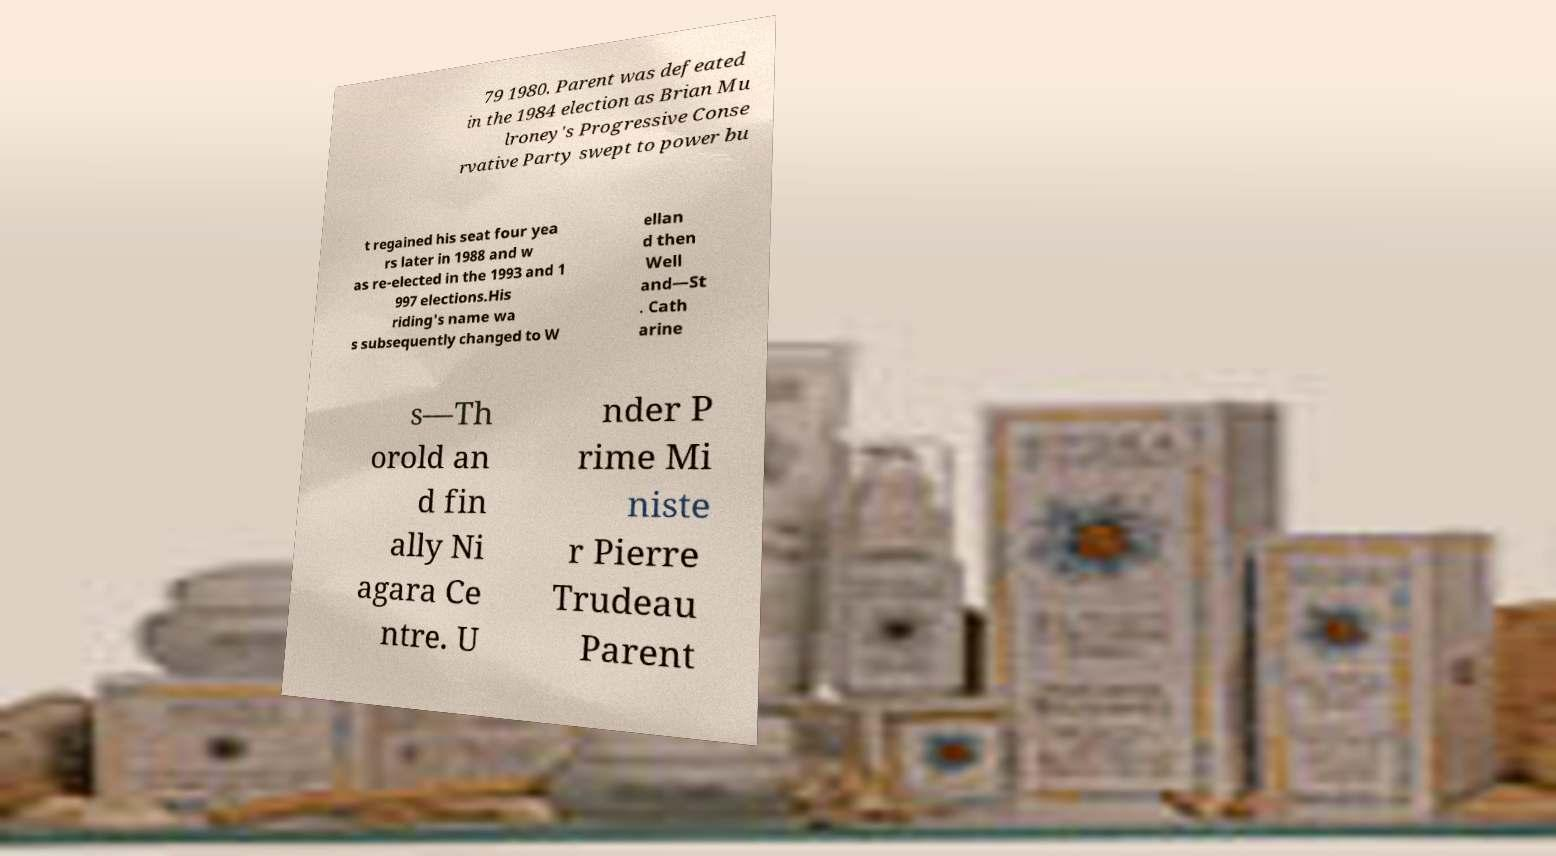What messages or text are displayed in this image? I need them in a readable, typed format. 79 1980. Parent was defeated in the 1984 election as Brian Mu lroney's Progressive Conse rvative Party swept to power bu t regained his seat four yea rs later in 1988 and w as re-elected in the 1993 and 1 997 elections.His riding's name wa s subsequently changed to W ellan d then Well and—St . Cath arine s—Th orold an d fin ally Ni agara Ce ntre. U nder P rime Mi niste r Pierre Trudeau Parent 